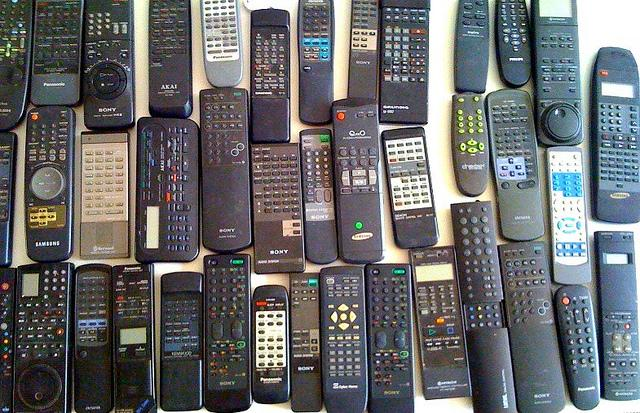Most of these items are probably used on what? televisions 